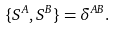<formula> <loc_0><loc_0><loc_500><loc_500>\{ S ^ { A } , S ^ { B } \} = \delta ^ { A B } .</formula> 